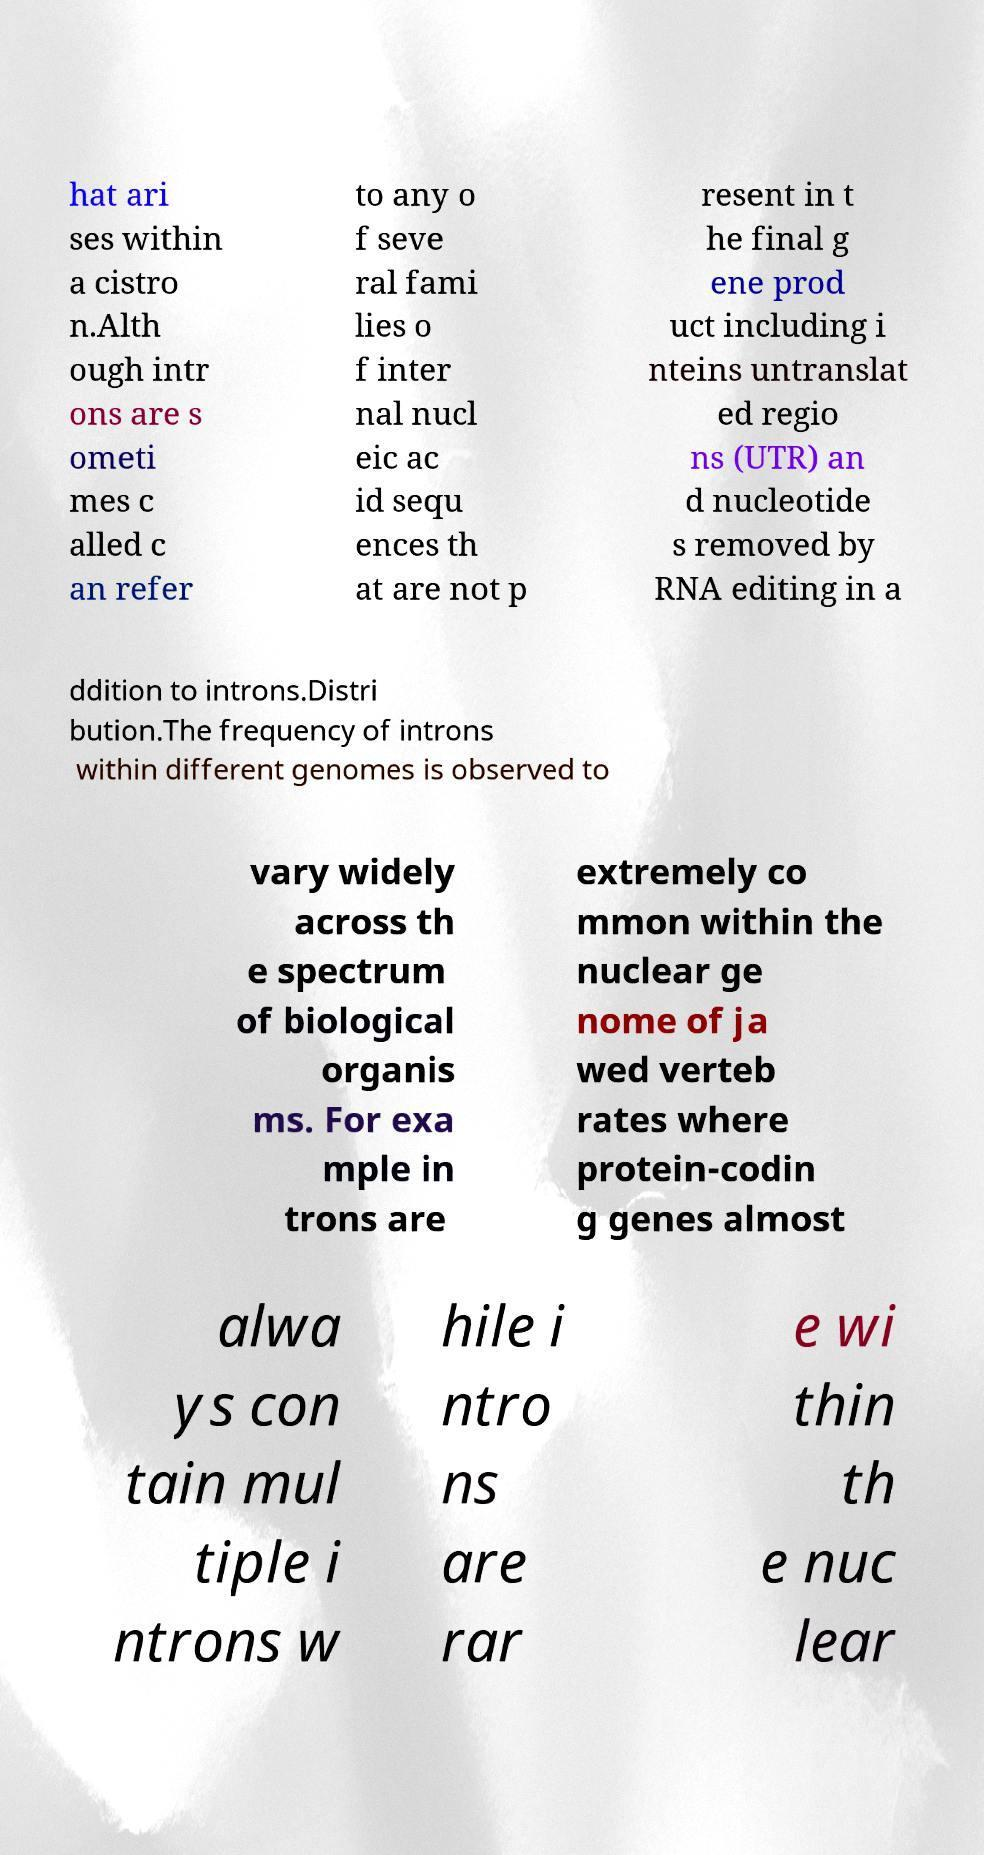Please identify and transcribe the text found in this image. hat ari ses within a cistro n.Alth ough intr ons are s ometi mes c alled c an refer to any o f seve ral fami lies o f inter nal nucl eic ac id sequ ences th at are not p resent in t he final g ene prod uct including i nteins untranslat ed regio ns (UTR) an d nucleotide s removed by RNA editing in a ddition to introns.Distri bution.The frequency of introns within different genomes is observed to vary widely across th e spectrum of biological organis ms. For exa mple in trons are extremely co mmon within the nuclear ge nome of ja wed verteb rates where protein-codin g genes almost alwa ys con tain mul tiple i ntrons w hile i ntro ns are rar e wi thin th e nuc lear 